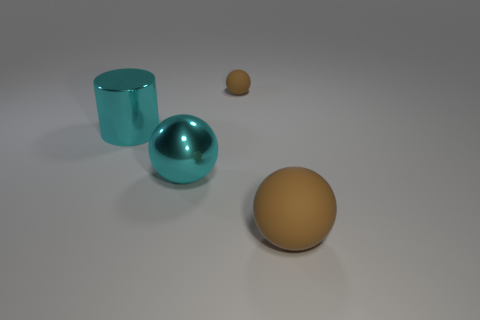Subtract all metal balls. How many balls are left? 2 Add 3 cyan balls. How many objects exist? 7 Subtract all cyan spheres. How many spheres are left? 2 Subtract all balls. How many objects are left? 1 Add 1 big rubber spheres. How many big rubber spheres are left? 2 Add 3 cyan cylinders. How many cyan cylinders exist? 4 Subtract 0 green balls. How many objects are left? 4 Subtract all gray balls. Subtract all yellow cylinders. How many balls are left? 3 Subtract all yellow cubes. How many brown spheres are left? 2 Subtract all cyan objects. Subtract all small gray metallic objects. How many objects are left? 2 